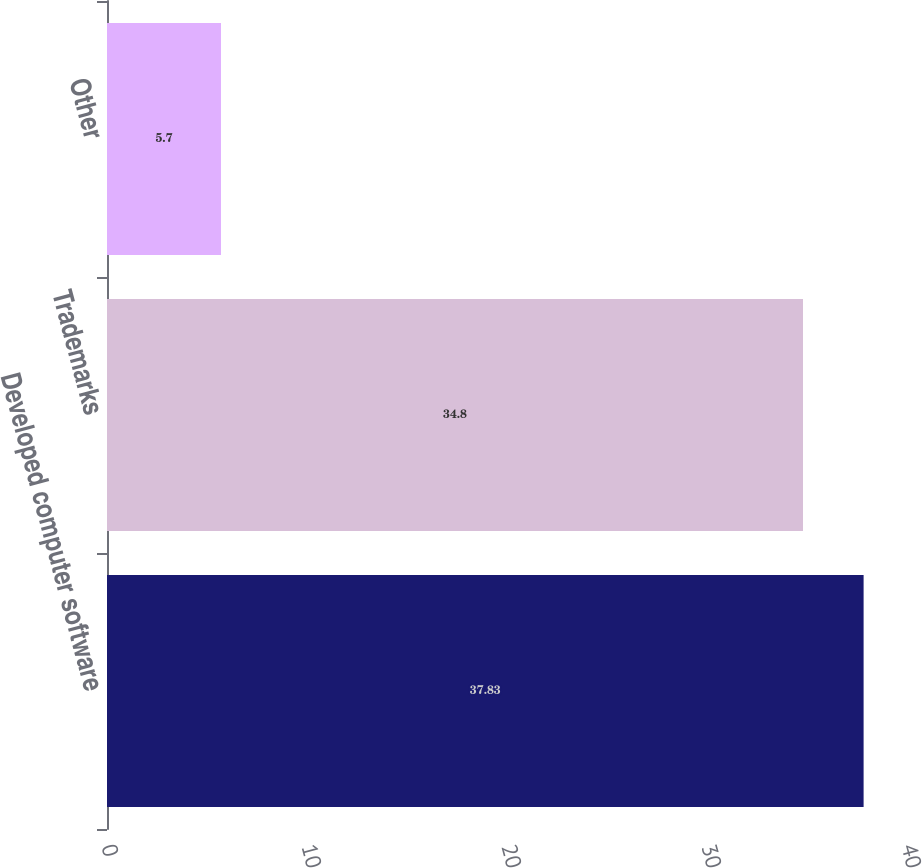Convert chart to OTSL. <chart><loc_0><loc_0><loc_500><loc_500><bar_chart><fcel>Developed computer software<fcel>Trademarks<fcel>Other<nl><fcel>37.83<fcel>34.8<fcel>5.7<nl></chart> 